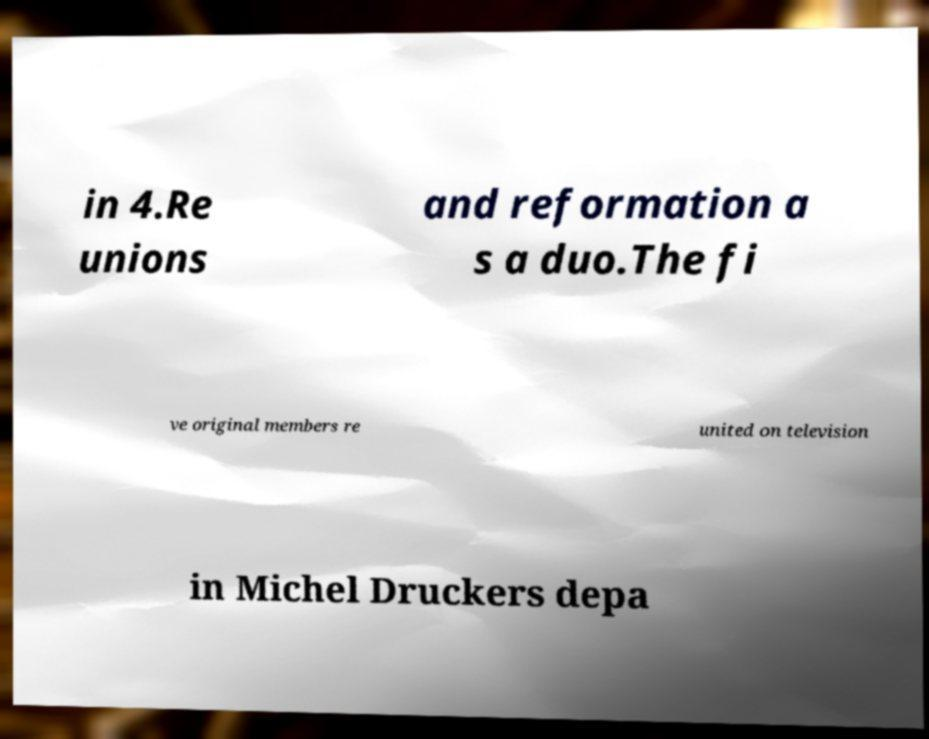Could you assist in decoding the text presented in this image and type it out clearly? in 4.Re unions and reformation a s a duo.The fi ve original members re united on television in Michel Druckers depa 